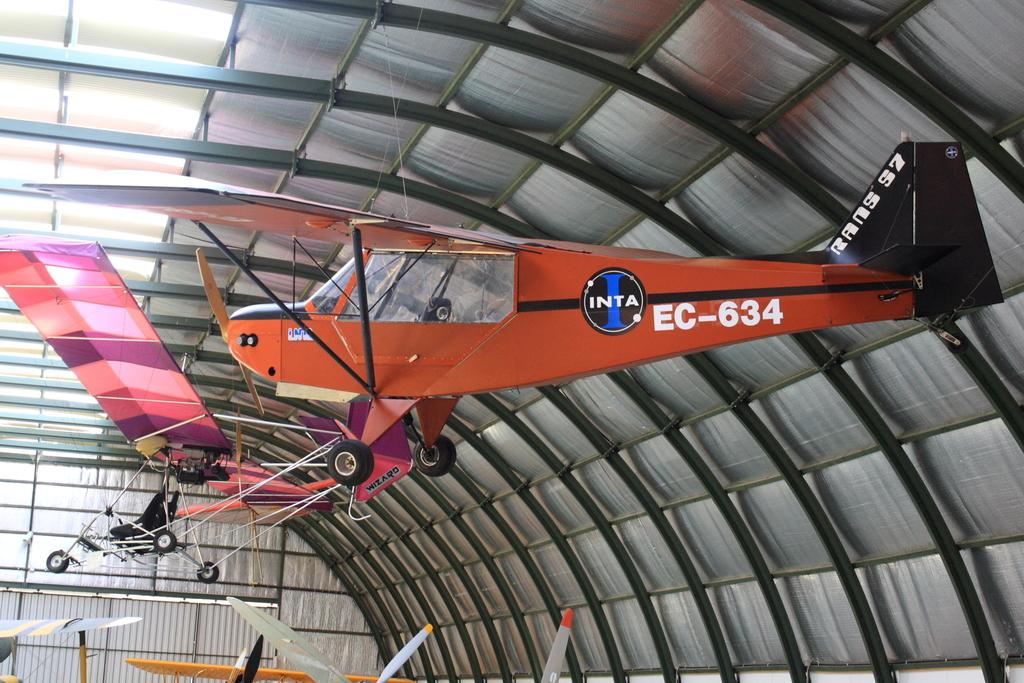<image>
Provide a brief description of the given image. a plane with the letters 'inta ec-634' on the side of it 